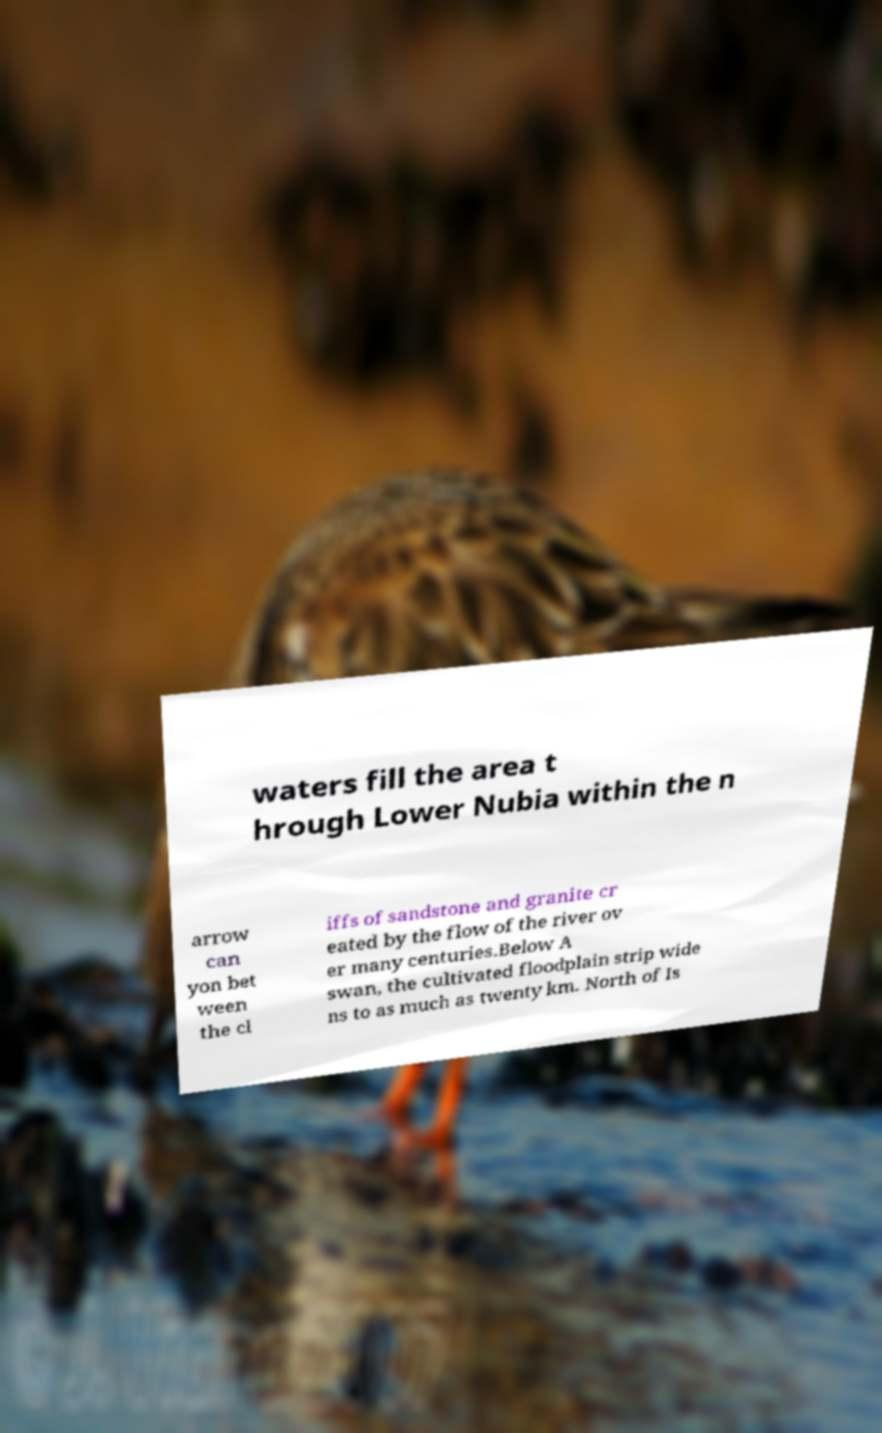Can you accurately transcribe the text from the provided image for me? waters fill the area t hrough Lower Nubia within the n arrow can yon bet ween the cl iffs of sandstone and granite cr eated by the flow of the river ov er many centuries.Below A swan, the cultivated floodplain strip wide ns to as much as twenty km. North of Is 